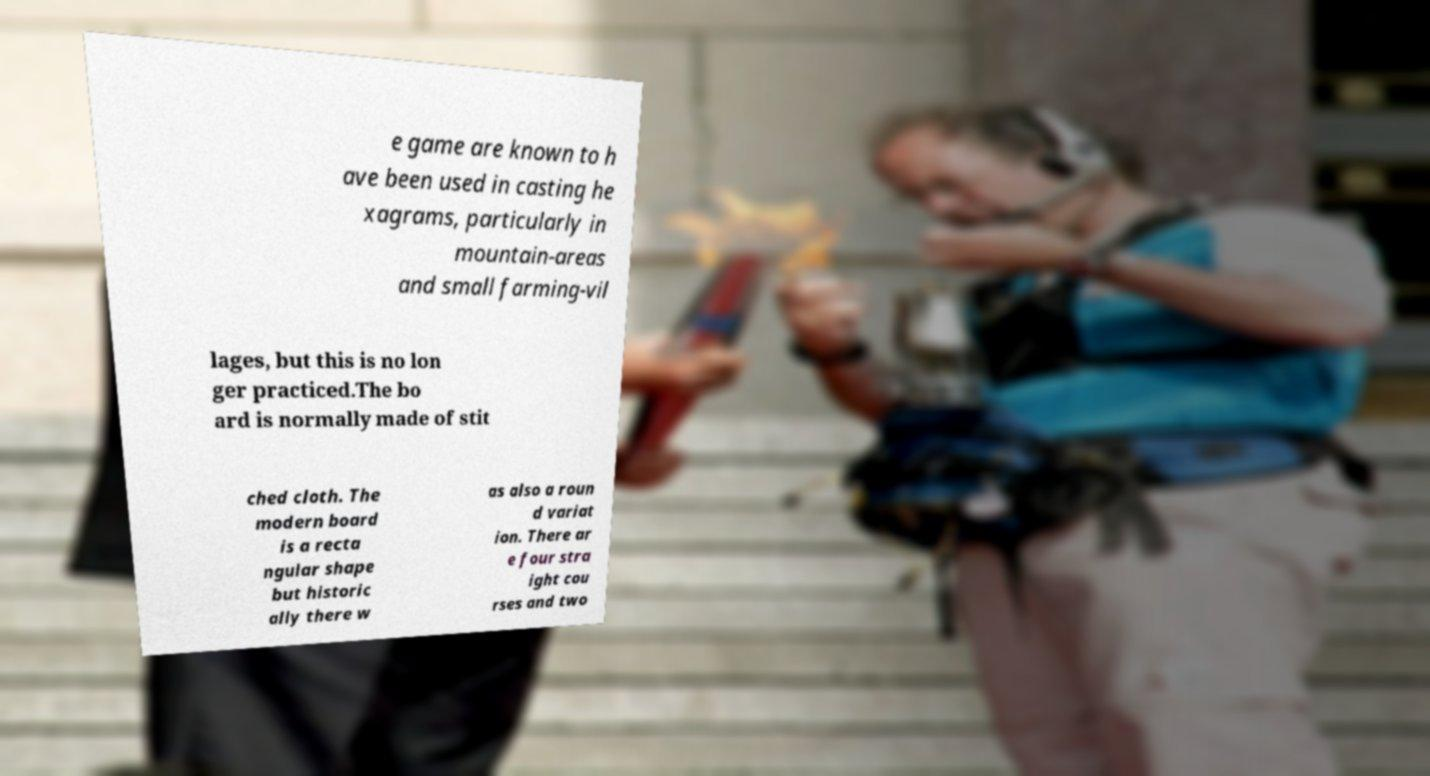I need the written content from this picture converted into text. Can you do that? e game are known to h ave been used in casting he xagrams, particularly in mountain-areas and small farming-vil lages, but this is no lon ger practiced.The bo ard is normally made of stit ched cloth. The modern board is a recta ngular shape but historic ally there w as also a roun d variat ion. There ar e four stra ight cou rses and two 